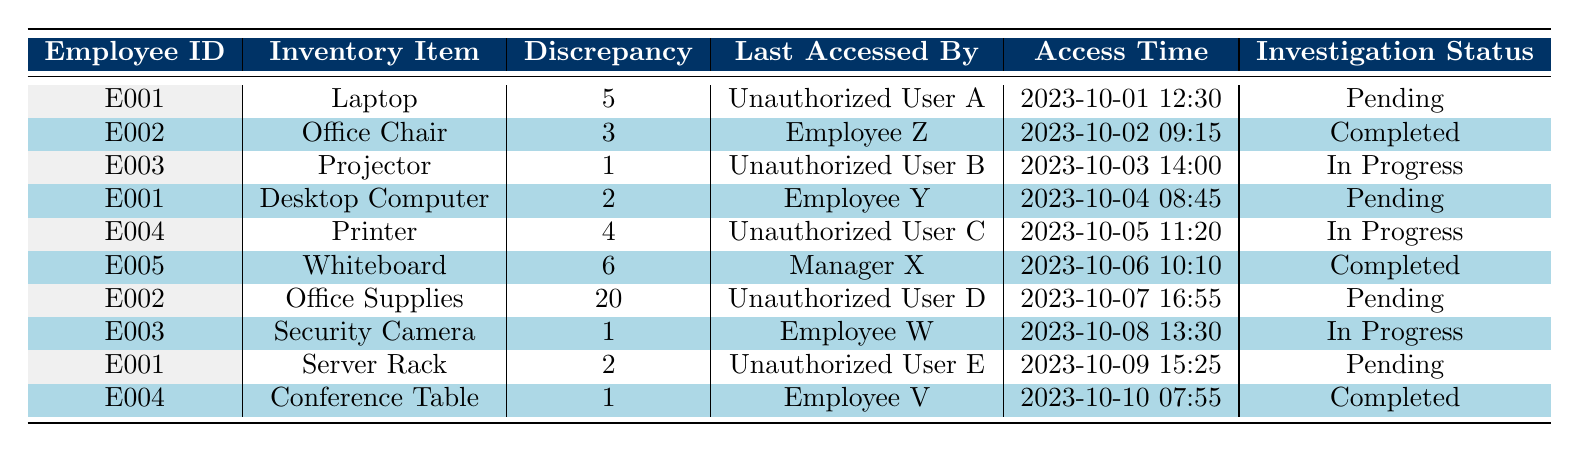What is the total discrepancy amount for items accessed by unauthorized users? We need to identify the discrepancy amounts for the items where the last accessed by is listed as an unauthorized user. Filtering the table, we find discrepancies of 5, 1, 4, and 20 for the items accessed by Unauthorized User A, B, C, and D. So, the total is 5 + 1 + 4 + 20 = 30.
Answer: 30 Which employee has the highest discrepancy amount? Reviewing the discrepancy amounts, we see that Employee E005 has a discrepancy of 6, while all others have lesser amounts (E002 has 20 from Office Supplies but is unauthorized). Therefore, the highest authorized discrepancy comes from E005.
Answer: E005 Is there any item that has an investigation status listed as "Completed"? Scanning the table, we see that the investigation status of items accessed by Employee Z, Manager X, and Employee V is marked as "Completed." Therefore, there are completed investigations.
Answer: Yes How many items are currently under investigation? The investigation status shows "In Progress" for the items accessed by Unauthorized User B, C, and Employee W. Therefore, there are 3 items currently under investigation.
Answer: 3 What is the average discrepancy amount for items accessed by unauthorized users? The discrepancies for items accessed by unauthorized users are 5, 1, 4, and 20. Summing these gives 30, and there are 4 items. The average is calculated as 30/4 = 7.5.
Answer: 7.5 Which specific item had the earliest access time? The access times listed in the table are: 2023-10-01, 2023-10-02, 2023-10-03, etc. The earliest time is for the Laptop accessed on 2023-10-01.
Answer: Laptop Are there any discrepancies linked to employees? Checking the table, we see entries for Employee Z, Employee Y, and Employee V, all of which have discrepancies linked to them. Thus, there are discrepancies associated with employees.
Answer: Yes What is the total number of discrepancies listed in the table? Counting each discrepancy amount in the table, we find there are 10 entries; therefore, the total number of discrepancies is simply this count.
Answer: 10 What is the discrepancy amount for the item accessed by Manager X? The table shows that the Whiteboard is the item accessed by Manager X, with a discrepancy amount of 6.
Answer: 6 